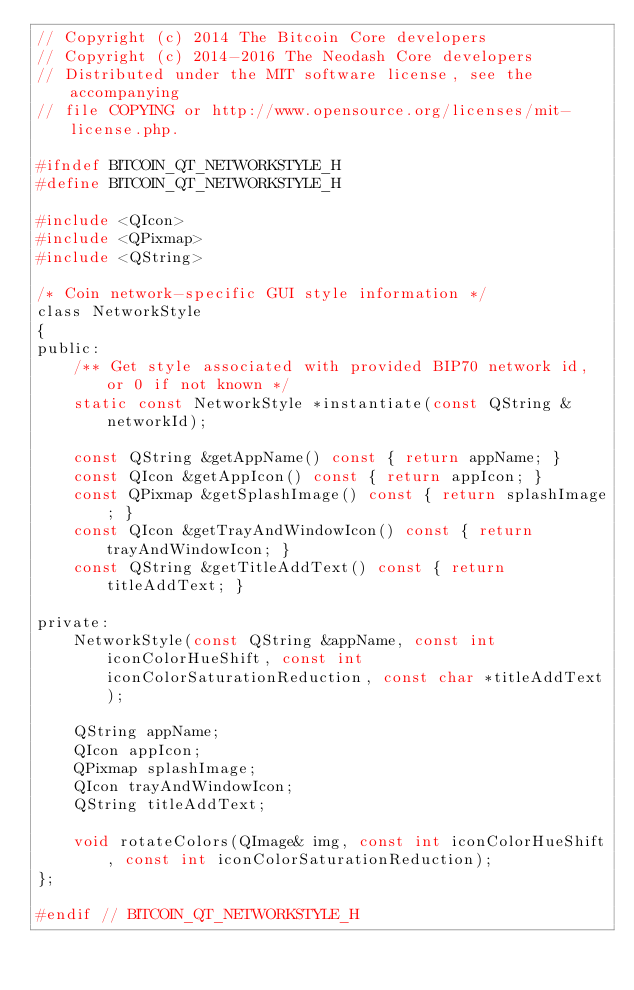<code> <loc_0><loc_0><loc_500><loc_500><_C_>// Copyright (c) 2014 The Bitcoin Core developers
// Copyright (c) 2014-2016 The Neodash Core developers
// Distributed under the MIT software license, see the accompanying
// file COPYING or http://www.opensource.org/licenses/mit-license.php.

#ifndef BITCOIN_QT_NETWORKSTYLE_H
#define BITCOIN_QT_NETWORKSTYLE_H

#include <QIcon>
#include <QPixmap>
#include <QString>

/* Coin network-specific GUI style information */
class NetworkStyle
{
public:
    /** Get style associated with provided BIP70 network id, or 0 if not known */
    static const NetworkStyle *instantiate(const QString &networkId);

    const QString &getAppName() const { return appName; }
    const QIcon &getAppIcon() const { return appIcon; }
    const QPixmap &getSplashImage() const { return splashImage; }
    const QIcon &getTrayAndWindowIcon() const { return trayAndWindowIcon; }
    const QString &getTitleAddText() const { return titleAddText; }

private:
    NetworkStyle(const QString &appName, const int iconColorHueShift, const int iconColorSaturationReduction, const char *titleAddText);

    QString appName;
    QIcon appIcon;
    QPixmap splashImage;
    QIcon trayAndWindowIcon;
    QString titleAddText;

    void rotateColors(QImage& img, const int iconColorHueShift, const int iconColorSaturationReduction);
};

#endif // BITCOIN_QT_NETWORKSTYLE_H
</code> 